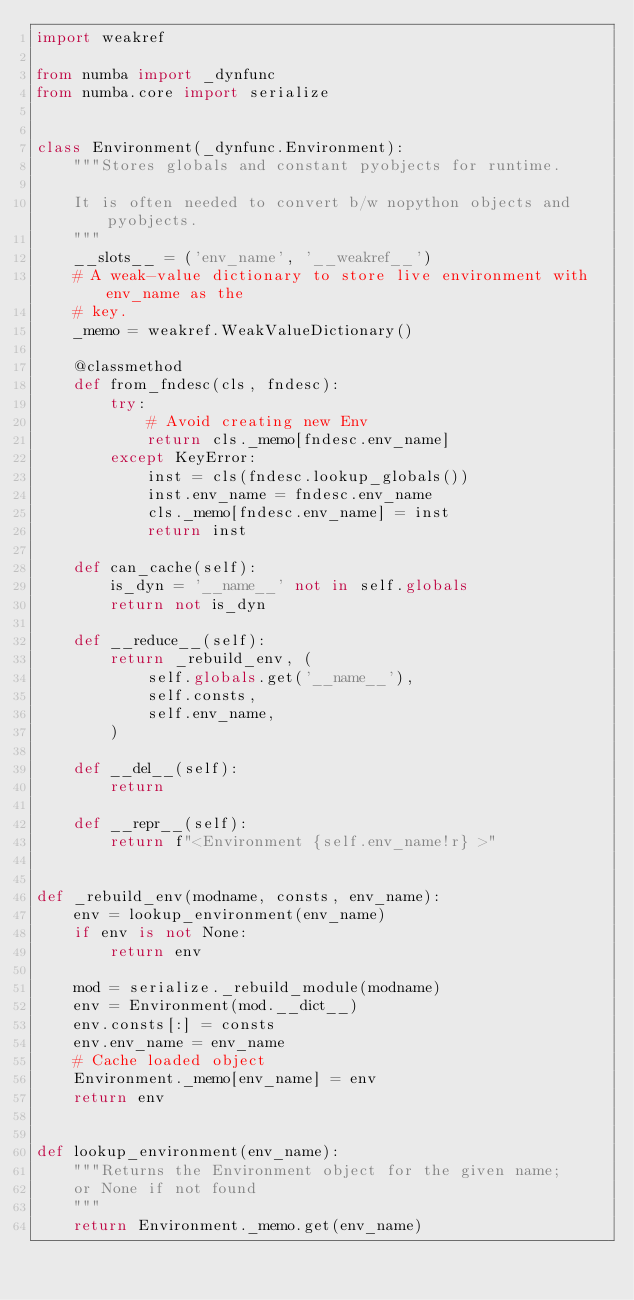Convert code to text. <code><loc_0><loc_0><loc_500><loc_500><_Python_>import weakref

from numba import _dynfunc
from numba.core import serialize


class Environment(_dynfunc.Environment):
    """Stores globals and constant pyobjects for runtime.

    It is often needed to convert b/w nopython objects and pyobjects.
    """
    __slots__ = ('env_name', '__weakref__')
    # A weak-value dictionary to store live environment with env_name as the
    # key.
    _memo = weakref.WeakValueDictionary()

    @classmethod
    def from_fndesc(cls, fndesc):
        try:
            # Avoid creating new Env
            return cls._memo[fndesc.env_name]
        except KeyError:
            inst = cls(fndesc.lookup_globals())
            inst.env_name = fndesc.env_name
            cls._memo[fndesc.env_name] = inst
            return inst

    def can_cache(self):
        is_dyn = '__name__' not in self.globals
        return not is_dyn

    def __reduce__(self):
        return _rebuild_env, (
            self.globals.get('__name__'),
            self.consts,
            self.env_name,
        )

    def __del__(self):
        return

    def __repr__(self):
        return f"<Environment {self.env_name!r} >"


def _rebuild_env(modname, consts, env_name):
    env = lookup_environment(env_name)
    if env is not None:
        return env

    mod = serialize._rebuild_module(modname)
    env = Environment(mod.__dict__)
    env.consts[:] = consts
    env.env_name = env_name
    # Cache loaded object
    Environment._memo[env_name] = env
    return env


def lookup_environment(env_name):
    """Returns the Environment object for the given name;
    or None if not found
    """
    return Environment._memo.get(env_name)
</code> 